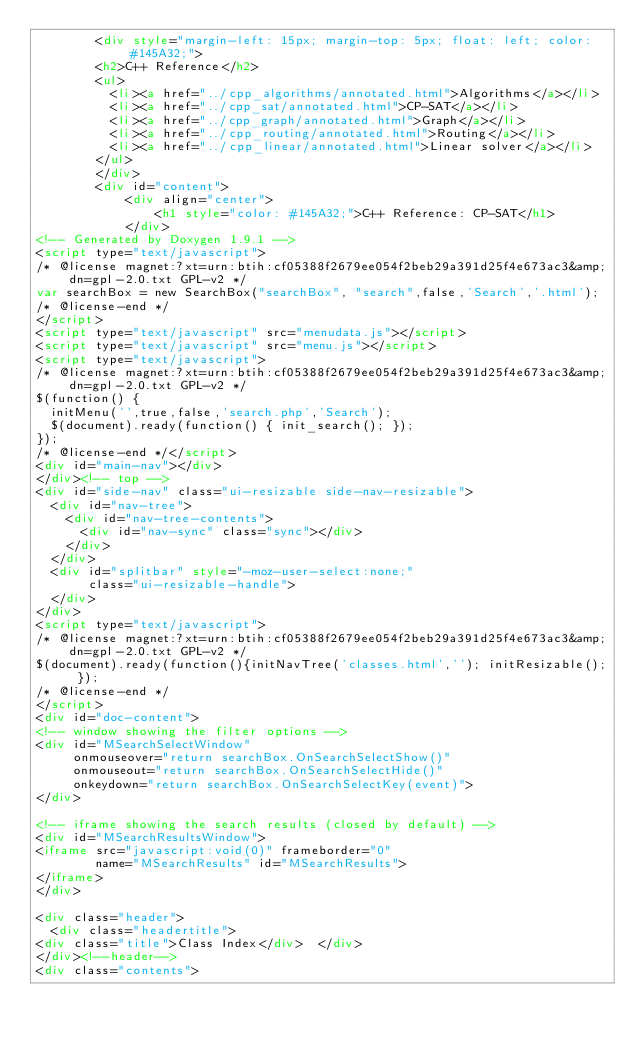Convert code to text. <code><loc_0><loc_0><loc_500><loc_500><_HTML_>        <div style="margin-left: 15px; margin-top: 5px; float: left; color: #145A32;">
        <h2>C++ Reference</h2>
        <ul>
          <li><a href="../cpp_algorithms/annotated.html">Algorithms</a></li>
          <li><a href="../cpp_sat/annotated.html">CP-SAT</a></li>
          <li><a href="../cpp_graph/annotated.html">Graph</a></li>
          <li><a href="../cpp_routing/annotated.html">Routing</a></li>
          <li><a href="../cpp_linear/annotated.html">Linear solver</a></li>
        </ul>
        </div>
        <div id="content">
            <div align="center">
                <h1 style="color: #145A32;">C++ Reference: CP-SAT</h1>
            </div>
<!-- Generated by Doxygen 1.9.1 -->
<script type="text/javascript">
/* @license magnet:?xt=urn:btih:cf05388f2679ee054f2beb29a391d25f4e673ac3&amp;dn=gpl-2.0.txt GPL-v2 */
var searchBox = new SearchBox("searchBox", "search",false,'Search','.html');
/* @license-end */
</script>
<script type="text/javascript" src="menudata.js"></script>
<script type="text/javascript" src="menu.js"></script>
<script type="text/javascript">
/* @license magnet:?xt=urn:btih:cf05388f2679ee054f2beb29a391d25f4e673ac3&amp;dn=gpl-2.0.txt GPL-v2 */
$(function() {
  initMenu('',true,false,'search.php','Search');
  $(document).ready(function() { init_search(); });
});
/* @license-end */</script>
<div id="main-nav"></div>
</div><!-- top -->
<div id="side-nav" class="ui-resizable side-nav-resizable">
  <div id="nav-tree">
    <div id="nav-tree-contents">
      <div id="nav-sync" class="sync"></div>
    </div>
  </div>
  <div id="splitbar" style="-moz-user-select:none;" 
       class="ui-resizable-handle">
  </div>
</div>
<script type="text/javascript">
/* @license magnet:?xt=urn:btih:cf05388f2679ee054f2beb29a391d25f4e673ac3&amp;dn=gpl-2.0.txt GPL-v2 */
$(document).ready(function(){initNavTree('classes.html',''); initResizable(); });
/* @license-end */
</script>
<div id="doc-content">
<!-- window showing the filter options -->
<div id="MSearchSelectWindow"
     onmouseover="return searchBox.OnSearchSelectShow()"
     onmouseout="return searchBox.OnSearchSelectHide()"
     onkeydown="return searchBox.OnSearchSelectKey(event)">
</div>

<!-- iframe showing the search results (closed by default) -->
<div id="MSearchResultsWindow">
<iframe src="javascript:void(0)" frameborder="0" 
        name="MSearchResults" id="MSearchResults">
</iframe>
</div>

<div class="header">
  <div class="headertitle">
<div class="title">Class Index</div>  </div>
</div><!--header-->
<div class="contents"></code> 